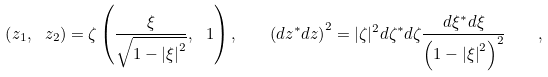Convert formula to latex. <formula><loc_0><loc_0><loc_500><loc_500>\left ( { { z _ { 1 } } , \ { z _ { 2 } } } \right ) = \zeta \left ( { { \frac { \xi } { \sqrt { 1 - \left | \xi \right | ^ { 2 } } } } , \ 1 } \right ) , \quad \left ( { d z ^ { * } d z } \right ) ^ { 2 } = | \zeta | ^ { 2 } d \zeta ^ { * } d \zeta { \frac { d \xi ^ { * } d \xi } { \left ( { 1 - \left | \xi \right | ^ { 2 } } \right ) ^ { 2 } } } \quad ,</formula> 